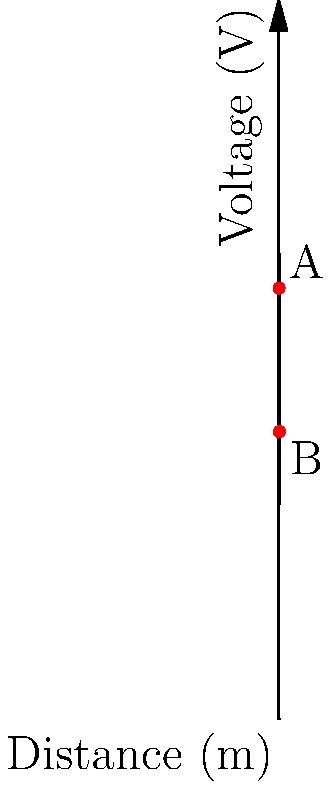You're inspecting your electric fence system and notice a voltage drop along the fence line. The graph shows the voltage measured at different distances from the fence energizer. At which point (A or B) is there likely a fault in the fence, and what could be causing this issue? To determine where the fault is likely to occur and its potential cause, let's analyze the voltage vs. distance graph step-by-step:

1. Observe the general trend: The voltage decreases linearly as the distance from the energizer increases. This is normal due to resistance in the fence wire.

2. Compare points A and B:
   - Point A (4m, 6000V): This point follows the expected linear decrease.
   - Point B (8m, 4000V): This point shows a more significant voltage drop than expected.

3. Calculate the voltage drop rate:
   - Between 0m and 4m: (8000V - 6000V) / 4m = 500 V/m
   - Between 4m and 8m: (6000V - 4000V) / 4m = 500 V/m

4. Analyze the results:
   The voltage drop rate is consistent throughout the fence, indicating no sudden large drops.

5. Identify the issue:
   Point B shows a lower voltage than expected, suggesting a gradual loss of power along the fence.

6. Potential causes:
   - Poor grounding: Inadequate grounding can cause voltage to "leak" into the soil.
   - Vegetation contact: Plants touching the fence can cause a gradual voltage drop.
   - Deteriorating insulators: Worn insulators may allow current to leak into fence posts.

Given the gradual nature of the voltage drop and its consistency, the most likely cause is vegetation contact or deteriorating insulators along the fence line, with the effects becoming more pronounced at point B.
Answer: Point B; likely caused by vegetation contact or deteriorating insulators. 